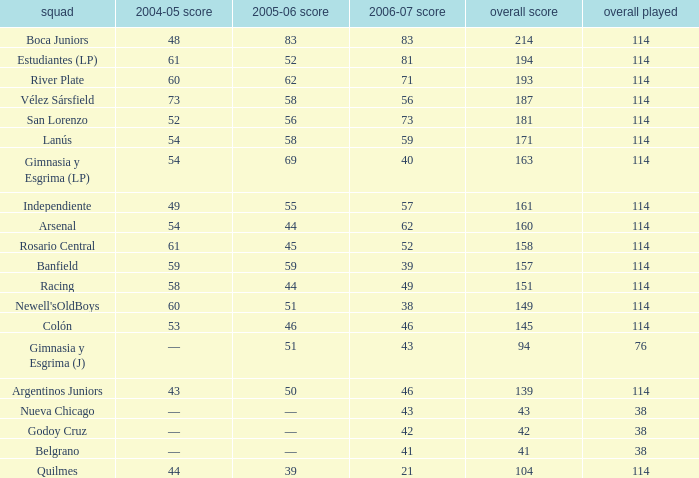What is the total number of PLD for Team Arsenal? 1.0. 